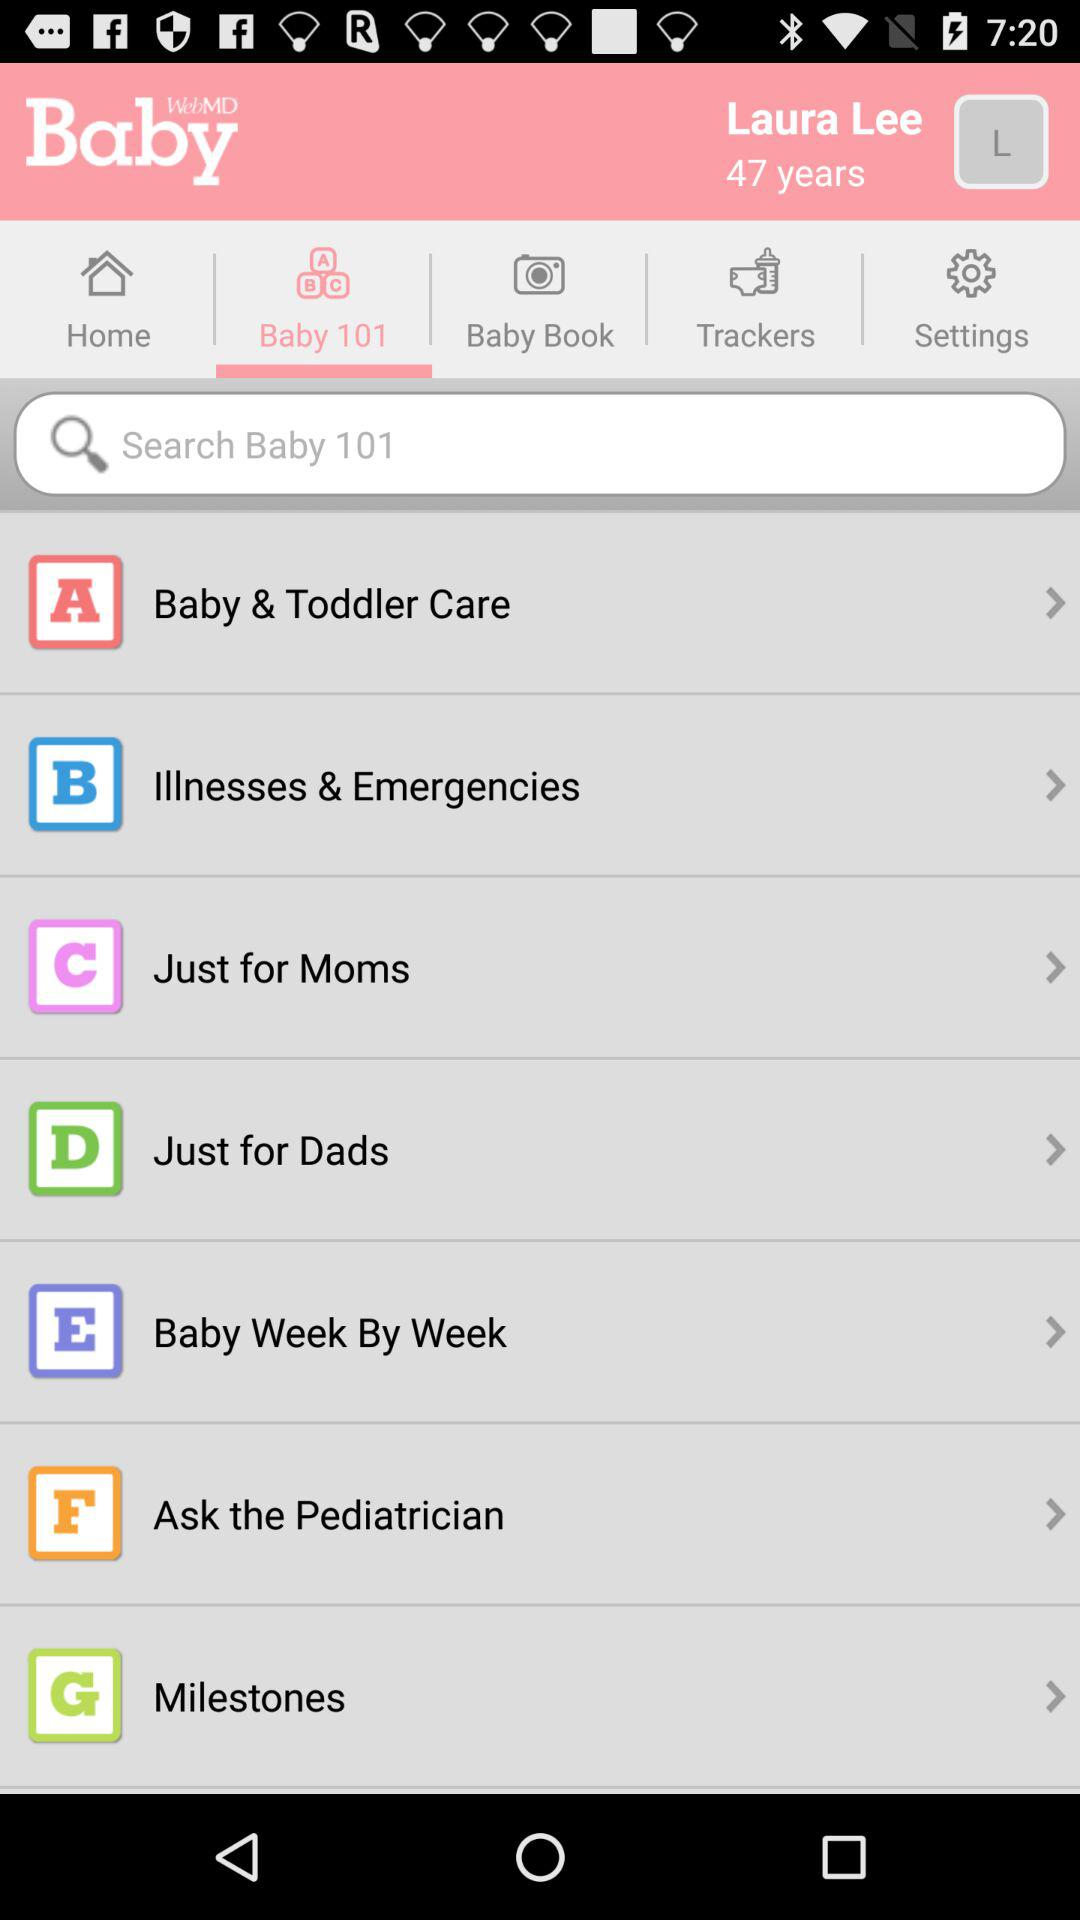What is the username? The username is Laura Lee. 